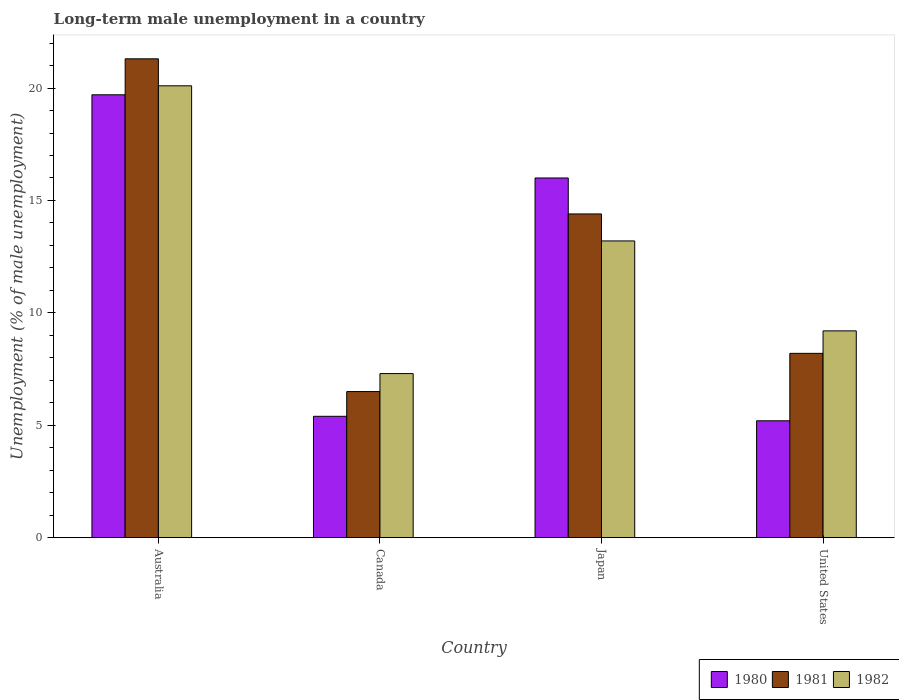How many groups of bars are there?
Your answer should be very brief. 4. Are the number of bars per tick equal to the number of legend labels?
Your answer should be very brief. Yes. Are the number of bars on each tick of the X-axis equal?
Give a very brief answer. Yes. How many bars are there on the 1st tick from the left?
Offer a very short reply. 3. How many bars are there on the 3rd tick from the right?
Make the answer very short. 3. What is the label of the 1st group of bars from the left?
Make the answer very short. Australia. In how many cases, is the number of bars for a given country not equal to the number of legend labels?
Provide a succinct answer. 0. What is the percentage of long-term unemployed male population in 1981 in Australia?
Offer a terse response. 21.3. Across all countries, what is the maximum percentage of long-term unemployed male population in 1981?
Offer a terse response. 21.3. Across all countries, what is the minimum percentage of long-term unemployed male population in 1982?
Provide a short and direct response. 7.3. In which country was the percentage of long-term unemployed male population in 1981 maximum?
Your response must be concise. Australia. In which country was the percentage of long-term unemployed male population in 1981 minimum?
Give a very brief answer. Canada. What is the total percentage of long-term unemployed male population in 1980 in the graph?
Offer a very short reply. 46.3. What is the difference between the percentage of long-term unemployed male population in 1982 in Canada and that in United States?
Your response must be concise. -1.9. What is the difference between the percentage of long-term unemployed male population in 1980 in United States and the percentage of long-term unemployed male population in 1982 in Japan?
Provide a succinct answer. -8. What is the average percentage of long-term unemployed male population in 1982 per country?
Provide a succinct answer. 12.45. What is the difference between the percentage of long-term unemployed male population of/in 1982 and percentage of long-term unemployed male population of/in 1980 in Canada?
Provide a short and direct response. 1.9. In how many countries, is the percentage of long-term unemployed male population in 1982 greater than 2 %?
Provide a succinct answer. 4. What is the ratio of the percentage of long-term unemployed male population in 1982 in Australia to that in United States?
Make the answer very short. 2.18. Is the difference between the percentage of long-term unemployed male population in 1982 in Australia and United States greater than the difference between the percentage of long-term unemployed male population in 1980 in Australia and United States?
Provide a short and direct response. No. What is the difference between the highest and the second highest percentage of long-term unemployed male population in 1981?
Offer a very short reply. -13.1. What is the difference between the highest and the lowest percentage of long-term unemployed male population in 1981?
Your answer should be very brief. 14.8. In how many countries, is the percentage of long-term unemployed male population in 1981 greater than the average percentage of long-term unemployed male population in 1981 taken over all countries?
Your response must be concise. 2. Is the sum of the percentage of long-term unemployed male population in 1981 in Australia and Canada greater than the maximum percentage of long-term unemployed male population in 1980 across all countries?
Offer a terse response. Yes. Is it the case that in every country, the sum of the percentage of long-term unemployed male population in 1980 and percentage of long-term unemployed male population in 1982 is greater than the percentage of long-term unemployed male population in 1981?
Keep it short and to the point. Yes. Does the graph contain any zero values?
Offer a terse response. No. Does the graph contain grids?
Make the answer very short. No. Where does the legend appear in the graph?
Your answer should be compact. Bottom right. How many legend labels are there?
Make the answer very short. 3. What is the title of the graph?
Offer a terse response. Long-term male unemployment in a country. Does "1965" appear as one of the legend labels in the graph?
Keep it short and to the point. No. What is the label or title of the X-axis?
Offer a terse response. Country. What is the label or title of the Y-axis?
Your answer should be compact. Unemployment (% of male unemployment). What is the Unemployment (% of male unemployment) in 1980 in Australia?
Your answer should be very brief. 19.7. What is the Unemployment (% of male unemployment) in 1981 in Australia?
Keep it short and to the point. 21.3. What is the Unemployment (% of male unemployment) in 1982 in Australia?
Your answer should be very brief. 20.1. What is the Unemployment (% of male unemployment) in 1980 in Canada?
Provide a short and direct response. 5.4. What is the Unemployment (% of male unemployment) in 1982 in Canada?
Offer a very short reply. 7.3. What is the Unemployment (% of male unemployment) in 1981 in Japan?
Make the answer very short. 14.4. What is the Unemployment (% of male unemployment) of 1982 in Japan?
Your answer should be compact. 13.2. What is the Unemployment (% of male unemployment) of 1980 in United States?
Your answer should be very brief. 5.2. What is the Unemployment (% of male unemployment) in 1981 in United States?
Your answer should be very brief. 8.2. What is the Unemployment (% of male unemployment) in 1982 in United States?
Provide a short and direct response. 9.2. Across all countries, what is the maximum Unemployment (% of male unemployment) of 1980?
Your answer should be compact. 19.7. Across all countries, what is the maximum Unemployment (% of male unemployment) of 1981?
Keep it short and to the point. 21.3. Across all countries, what is the maximum Unemployment (% of male unemployment) in 1982?
Keep it short and to the point. 20.1. Across all countries, what is the minimum Unemployment (% of male unemployment) of 1980?
Give a very brief answer. 5.2. Across all countries, what is the minimum Unemployment (% of male unemployment) of 1982?
Make the answer very short. 7.3. What is the total Unemployment (% of male unemployment) of 1980 in the graph?
Give a very brief answer. 46.3. What is the total Unemployment (% of male unemployment) of 1981 in the graph?
Make the answer very short. 50.4. What is the total Unemployment (% of male unemployment) in 1982 in the graph?
Your response must be concise. 49.8. What is the difference between the Unemployment (% of male unemployment) in 1981 in Australia and that in Japan?
Keep it short and to the point. 6.9. What is the difference between the Unemployment (% of male unemployment) in 1982 in Australia and that in Japan?
Ensure brevity in your answer.  6.9. What is the difference between the Unemployment (% of male unemployment) in 1980 in Australia and that in United States?
Give a very brief answer. 14.5. What is the difference between the Unemployment (% of male unemployment) of 1980 in Canada and that in Japan?
Your response must be concise. -10.6. What is the difference between the Unemployment (% of male unemployment) of 1981 in Canada and that in Japan?
Keep it short and to the point. -7.9. What is the difference between the Unemployment (% of male unemployment) in 1980 in Canada and that in United States?
Provide a short and direct response. 0.2. What is the difference between the Unemployment (% of male unemployment) of 1980 in Australia and the Unemployment (% of male unemployment) of 1981 in Canada?
Provide a succinct answer. 13.2. What is the difference between the Unemployment (% of male unemployment) of 1980 in Australia and the Unemployment (% of male unemployment) of 1982 in Canada?
Your answer should be very brief. 12.4. What is the difference between the Unemployment (% of male unemployment) of 1980 in Australia and the Unemployment (% of male unemployment) of 1981 in Japan?
Your answer should be compact. 5.3. What is the difference between the Unemployment (% of male unemployment) in 1981 in Australia and the Unemployment (% of male unemployment) in 1982 in Japan?
Offer a terse response. 8.1. What is the difference between the Unemployment (% of male unemployment) in 1980 in Canada and the Unemployment (% of male unemployment) in 1981 in Japan?
Your answer should be compact. -9. What is the difference between the Unemployment (% of male unemployment) in 1981 in Canada and the Unemployment (% of male unemployment) in 1982 in United States?
Provide a short and direct response. -2.7. What is the difference between the Unemployment (% of male unemployment) in 1980 in Japan and the Unemployment (% of male unemployment) in 1981 in United States?
Offer a terse response. 7.8. What is the difference between the Unemployment (% of male unemployment) in 1980 in Japan and the Unemployment (% of male unemployment) in 1982 in United States?
Your response must be concise. 6.8. What is the difference between the Unemployment (% of male unemployment) of 1981 in Japan and the Unemployment (% of male unemployment) of 1982 in United States?
Offer a very short reply. 5.2. What is the average Unemployment (% of male unemployment) in 1980 per country?
Give a very brief answer. 11.57. What is the average Unemployment (% of male unemployment) of 1981 per country?
Your answer should be compact. 12.6. What is the average Unemployment (% of male unemployment) of 1982 per country?
Give a very brief answer. 12.45. What is the difference between the Unemployment (% of male unemployment) in 1980 and Unemployment (% of male unemployment) in 1981 in Australia?
Give a very brief answer. -1.6. What is the difference between the Unemployment (% of male unemployment) in 1981 and Unemployment (% of male unemployment) in 1982 in Australia?
Offer a very short reply. 1.2. What is the difference between the Unemployment (% of male unemployment) of 1980 and Unemployment (% of male unemployment) of 1982 in Canada?
Offer a very short reply. -1.9. What is the difference between the Unemployment (% of male unemployment) of 1981 and Unemployment (% of male unemployment) of 1982 in Canada?
Make the answer very short. -0.8. What is the difference between the Unemployment (% of male unemployment) of 1980 and Unemployment (% of male unemployment) of 1981 in Japan?
Your answer should be compact. 1.6. What is the difference between the Unemployment (% of male unemployment) of 1980 and Unemployment (% of male unemployment) of 1982 in United States?
Keep it short and to the point. -4. What is the ratio of the Unemployment (% of male unemployment) of 1980 in Australia to that in Canada?
Your response must be concise. 3.65. What is the ratio of the Unemployment (% of male unemployment) of 1981 in Australia to that in Canada?
Provide a short and direct response. 3.28. What is the ratio of the Unemployment (% of male unemployment) of 1982 in Australia to that in Canada?
Your answer should be compact. 2.75. What is the ratio of the Unemployment (% of male unemployment) of 1980 in Australia to that in Japan?
Your response must be concise. 1.23. What is the ratio of the Unemployment (% of male unemployment) in 1981 in Australia to that in Japan?
Your answer should be compact. 1.48. What is the ratio of the Unemployment (% of male unemployment) in 1982 in Australia to that in Japan?
Give a very brief answer. 1.52. What is the ratio of the Unemployment (% of male unemployment) of 1980 in Australia to that in United States?
Give a very brief answer. 3.79. What is the ratio of the Unemployment (% of male unemployment) of 1981 in Australia to that in United States?
Give a very brief answer. 2.6. What is the ratio of the Unemployment (% of male unemployment) of 1982 in Australia to that in United States?
Offer a very short reply. 2.18. What is the ratio of the Unemployment (% of male unemployment) in 1980 in Canada to that in Japan?
Give a very brief answer. 0.34. What is the ratio of the Unemployment (% of male unemployment) of 1981 in Canada to that in Japan?
Offer a terse response. 0.45. What is the ratio of the Unemployment (% of male unemployment) in 1982 in Canada to that in Japan?
Your response must be concise. 0.55. What is the ratio of the Unemployment (% of male unemployment) in 1981 in Canada to that in United States?
Ensure brevity in your answer.  0.79. What is the ratio of the Unemployment (% of male unemployment) in 1982 in Canada to that in United States?
Provide a short and direct response. 0.79. What is the ratio of the Unemployment (% of male unemployment) in 1980 in Japan to that in United States?
Your answer should be compact. 3.08. What is the ratio of the Unemployment (% of male unemployment) of 1981 in Japan to that in United States?
Your response must be concise. 1.76. What is the ratio of the Unemployment (% of male unemployment) of 1982 in Japan to that in United States?
Give a very brief answer. 1.43. What is the difference between the highest and the second highest Unemployment (% of male unemployment) in 1980?
Provide a succinct answer. 3.7. 